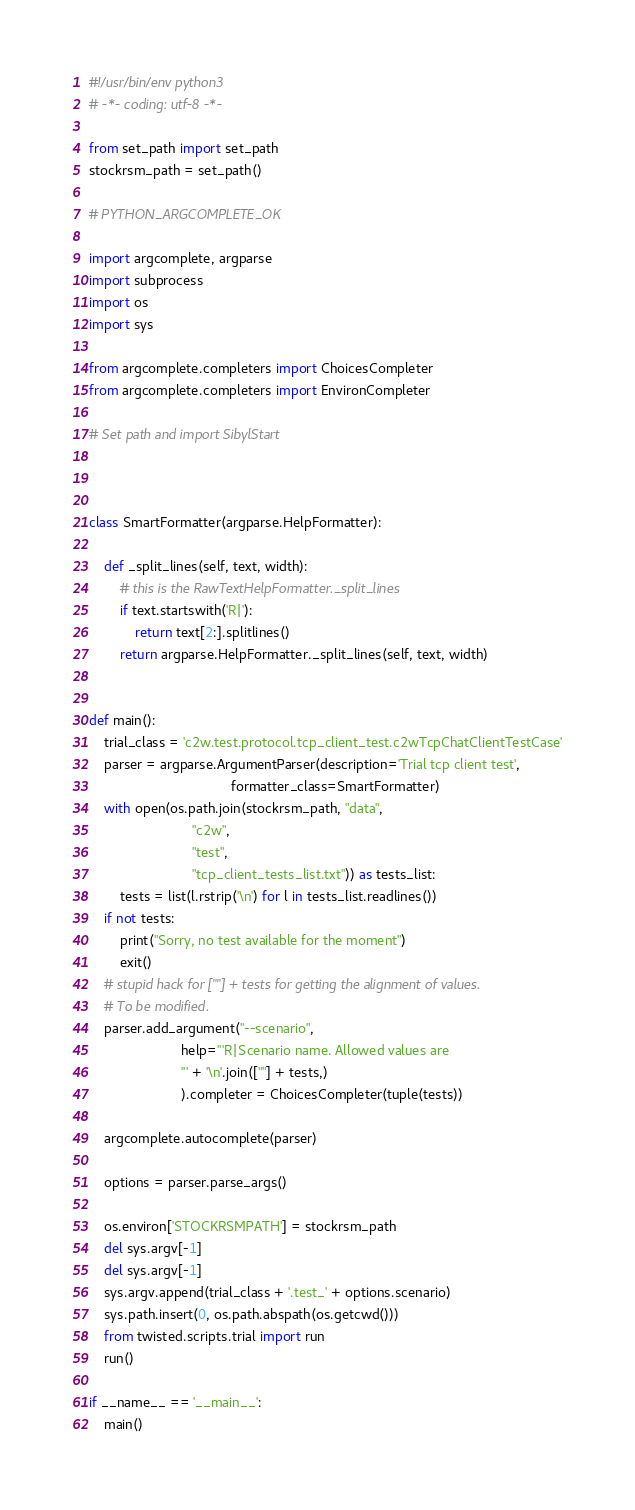<code> <loc_0><loc_0><loc_500><loc_500><_Python_>#!/usr/bin/env python3
# -*- coding: utf-8 -*-

from set_path import set_path
stockrsm_path = set_path()

# PYTHON_ARGCOMPLETE_OK

import argcomplete, argparse
import subprocess
import os
import sys

from argcomplete.completers import ChoicesCompleter
from argcomplete.completers import EnvironCompleter

# Set path and import SibylStart



class SmartFormatter(argparse.HelpFormatter):

    def _split_lines(self, text, width):
        # this is the RawTextHelpFormatter._split_lines
        if text.startswith('R|'):
            return text[2:].splitlines()
        return argparse.HelpFormatter._split_lines(self, text, width)


def main():
    trial_class = 'c2w.test.protocol.tcp_client_test.c2wTcpChatClientTestCase'
    parser = argparse.ArgumentParser(description='Trial tcp client test',
                                     formatter_class=SmartFormatter)
    with open(os.path.join(stockrsm_path, "data",
                           "c2w",
                           "test",
                           "tcp_client_tests_list.txt")) as tests_list:
        tests = list(l.rstrip('\n') for l in tests_list.readlines())
    if not tests:
        print("Sorry, no test available for the moment")
        exit()
    # stupid hack for [""] + tests for getting the alignment of values.
    # To be modified.
    parser.add_argument("--scenario",
                        help='''R|Scenario name. Allowed values are
                        ''' + '\n'.join([""] + tests,)
                        ).completer = ChoicesCompleter(tuple(tests))

    argcomplete.autocomplete(parser)

    options = parser.parse_args()
    
    os.environ['STOCKRSMPATH'] = stockrsm_path
    del sys.argv[-1]
    del sys.argv[-1]
    sys.argv.append(trial_class + '.test_' + options.scenario)    
    sys.path.insert(0, os.path.abspath(os.getcwd()))
    from twisted.scripts.trial import run    
    run()

if __name__ == '__main__':
    main()
</code> 